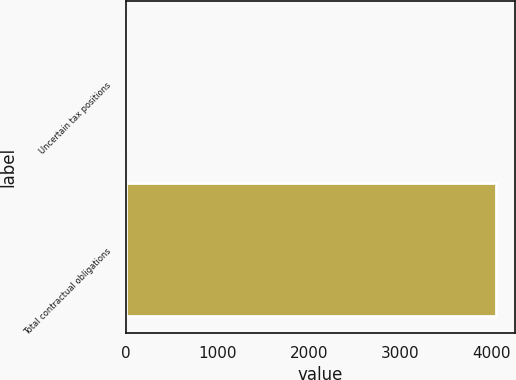Convert chart. <chart><loc_0><loc_0><loc_500><loc_500><bar_chart><fcel>Uncertain tax positions<fcel>Total contractual obligations<nl><fcel>0.9<fcel>4051<nl></chart> 